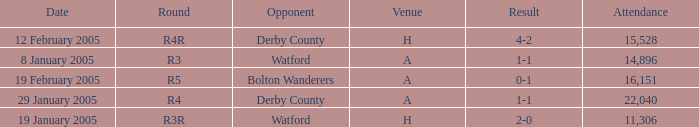What is the date where the round is R3? 8 January 2005. 